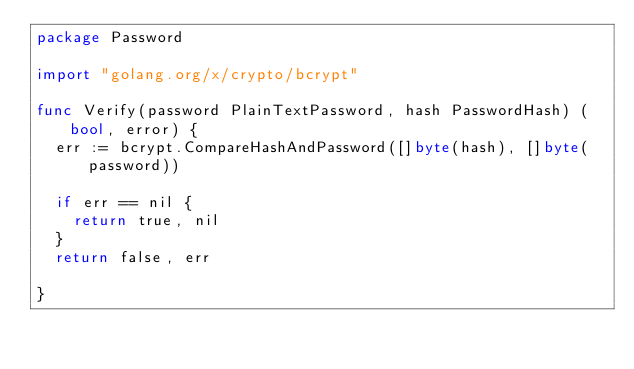Convert code to text. <code><loc_0><loc_0><loc_500><loc_500><_Go_>package Password

import "golang.org/x/crypto/bcrypt"

func Verify(password PlainTextPassword, hash PasswordHash) (bool, error) {
	err := bcrypt.CompareHashAndPassword([]byte(hash), []byte(password))

	if err == nil {
		return true, nil
	}
	return false, err

}
</code> 